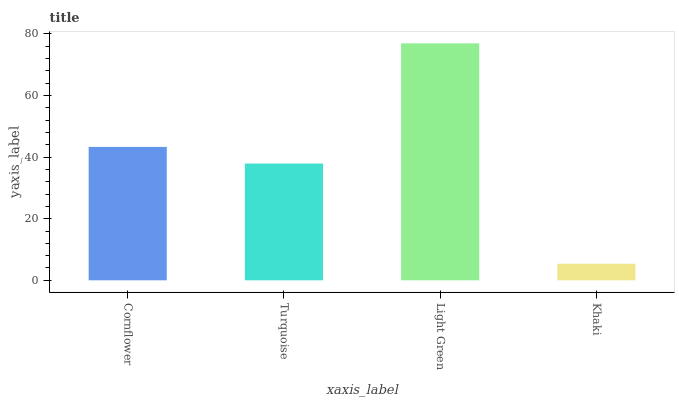Is Khaki the minimum?
Answer yes or no. Yes. Is Light Green the maximum?
Answer yes or no. Yes. Is Turquoise the minimum?
Answer yes or no. No. Is Turquoise the maximum?
Answer yes or no. No. Is Cornflower greater than Turquoise?
Answer yes or no. Yes. Is Turquoise less than Cornflower?
Answer yes or no. Yes. Is Turquoise greater than Cornflower?
Answer yes or no. No. Is Cornflower less than Turquoise?
Answer yes or no. No. Is Cornflower the high median?
Answer yes or no. Yes. Is Turquoise the low median?
Answer yes or no. Yes. Is Khaki the high median?
Answer yes or no. No. Is Light Green the low median?
Answer yes or no. No. 